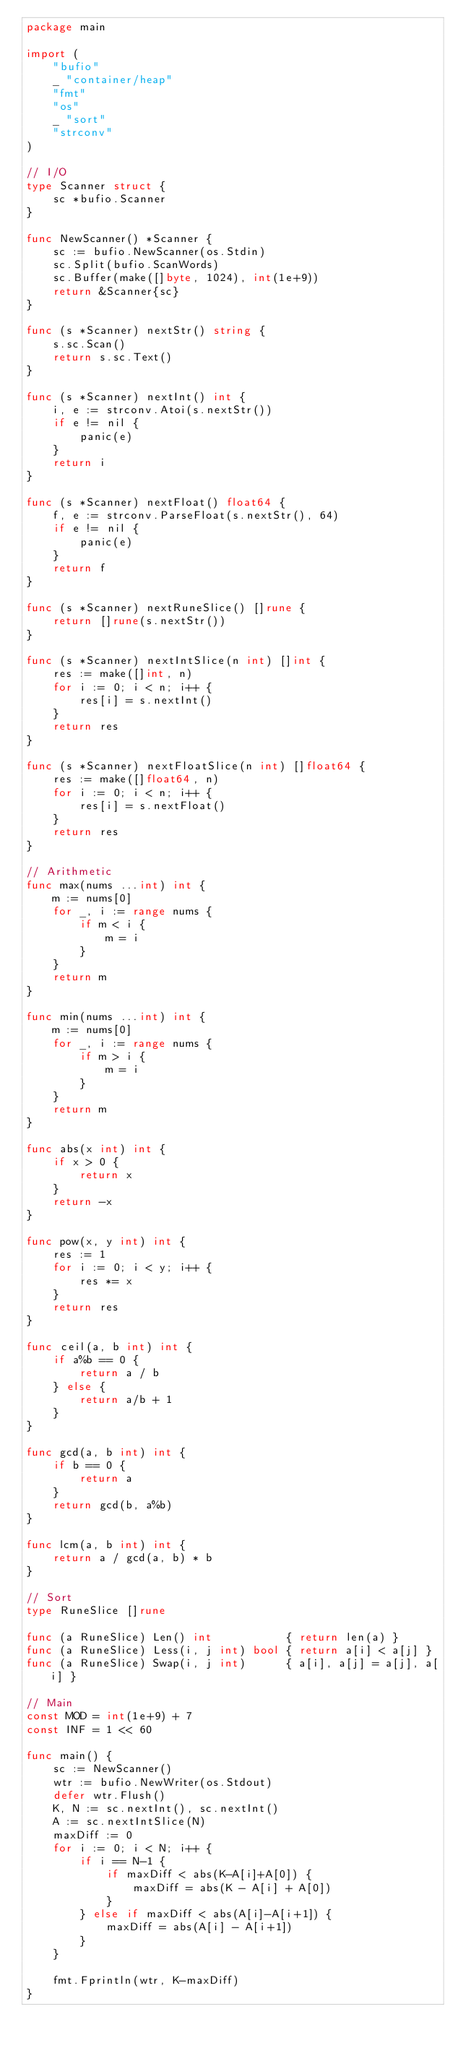Convert code to text. <code><loc_0><loc_0><loc_500><loc_500><_Go_>package main

import (
	"bufio"
	_ "container/heap"
	"fmt"
	"os"
	_ "sort"
	"strconv"
)

// I/O
type Scanner struct {
	sc *bufio.Scanner
}

func NewScanner() *Scanner {
	sc := bufio.NewScanner(os.Stdin)
	sc.Split(bufio.ScanWords)
	sc.Buffer(make([]byte, 1024), int(1e+9))
	return &Scanner{sc}
}

func (s *Scanner) nextStr() string {
	s.sc.Scan()
	return s.sc.Text()
}

func (s *Scanner) nextInt() int {
	i, e := strconv.Atoi(s.nextStr())
	if e != nil {
		panic(e)
	}
	return i
}

func (s *Scanner) nextFloat() float64 {
	f, e := strconv.ParseFloat(s.nextStr(), 64)
	if e != nil {
		panic(e)
	}
	return f
}

func (s *Scanner) nextRuneSlice() []rune {
	return []rune(s.nextStr())
}

func (s *Scanner) nextIntSlice(n int) []int {
	res := make([]int, n)
	for i := 0; i < n; i++ {
		res[i] = s.nextInt()
	}
	return res
}

func (s *Scanner) nextFloatSlice(n int) []float64 {
	res := make([]float64, n)
	for i := 0; i < n; i++ {
		res[i] = s.nextFloat()
	}
	return res
}

// Arithmetic
func max(nums ...int) int {
	m := nums[0]
	for _, i := range nums {
		if m < i {
			m = i
		}
	}
	return m
}

func min(nums ...int) int {
	m := nums[0]
	for _, i := range nums {
		if m > i {
			m = i
		}
	}
	return m
}

func abs(x int) int {
	if x > 0 {
		return x
	}
	return -x
}

func pow(x, y int) int {
	res := 1
	for i := 0; i < y; i++ {
		res *= x
	}
	return res
}

func ceil(a, b int) int {
	if a%b == 0 {
		return a / b
	} else {
		return a/b + 1
	}
}

func gcd(a, b int) int {
	if b == 0 {
		return a
	}
	return gcd(b, a%b)
}

func lcm(a, b int) int {
	return a / gcd(a, b) * b
}

// Sort
type RuneSlice []rune

func (a RuneSlice) Len() int           { return len(a) }
func (a RuneSlice) Less(i, j int) bool { return a[i] < a[j] }
func (a RuneSlice) Swap(i, j int)      { a[i], a[j] = a[j], a[i] }

// Main
const MOD = int(1e+9) + 7
const INF = 1 << 60

func main() {
	sc := NewScanner()
	wtr := bufio.NewWriter(os.Stdout)
	defer wtr.Flush()
	K, N := sc.nextInt(), sc.nextInt()
	A := sc.nextIntSlice(N)
	maxDiff := 0
	for i := 0; i < N; i++ {
		if i == N-1 {
			if maxDiff < abs(K-A[i]+A[0]) {
				maxDiff = abs(K - A[i] + A[0])
			}
		} else if maxDiff < abs(A[i]-A[i+1]) {
			maxDiff = abs(A[i] - A[i+1])
		}
	}

	fmt.Fprintln(wtr, K-maxDiff)
}
</code> 